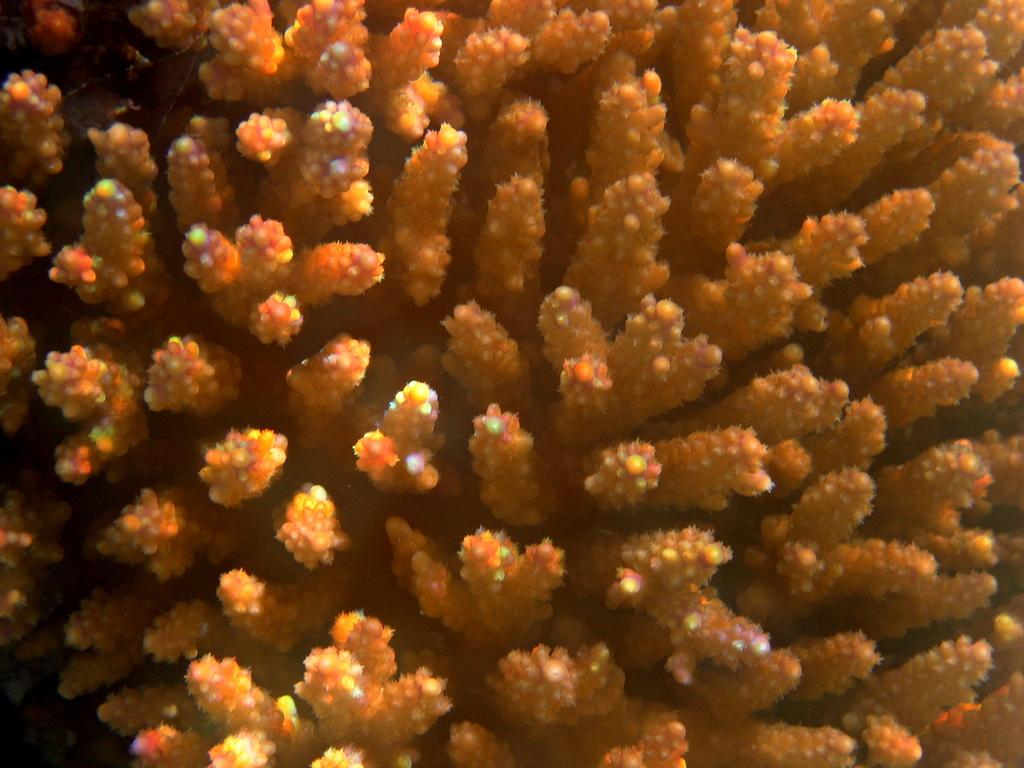What type of living organisms can be seen in the image? Plants can be seen in the image. What type of sea creatures can be seen swimming in the image? There are no sea creatures visible in the image, as it only contains plants. 